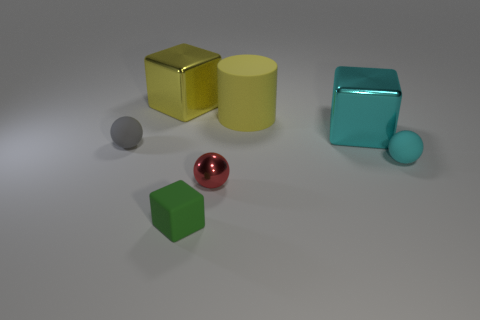Subtract all small rubber spheres. How many spheres are left? 1 Add 3 gray rubber balls. How many objects exist? 10 Subtract all gray spheres. How many spheres are left? 2 Subtract all cylinders. How many objects are left? 6 Subtract 1 cylinders. How many cylinders are left? 0 Subtract all gray spheres. Subtract all yellow rubber things. How many objects are left? 5 Add 4 large cyan things. How many large cyan things are left? 5 Add 4 small blue metallic balls. How many small blue metallic balls exist? 4 Subtract 1 gray spheres. How many objects are left? 6 Subtract all green balls. Subtract all gray cubes. How many balls are left? 3 